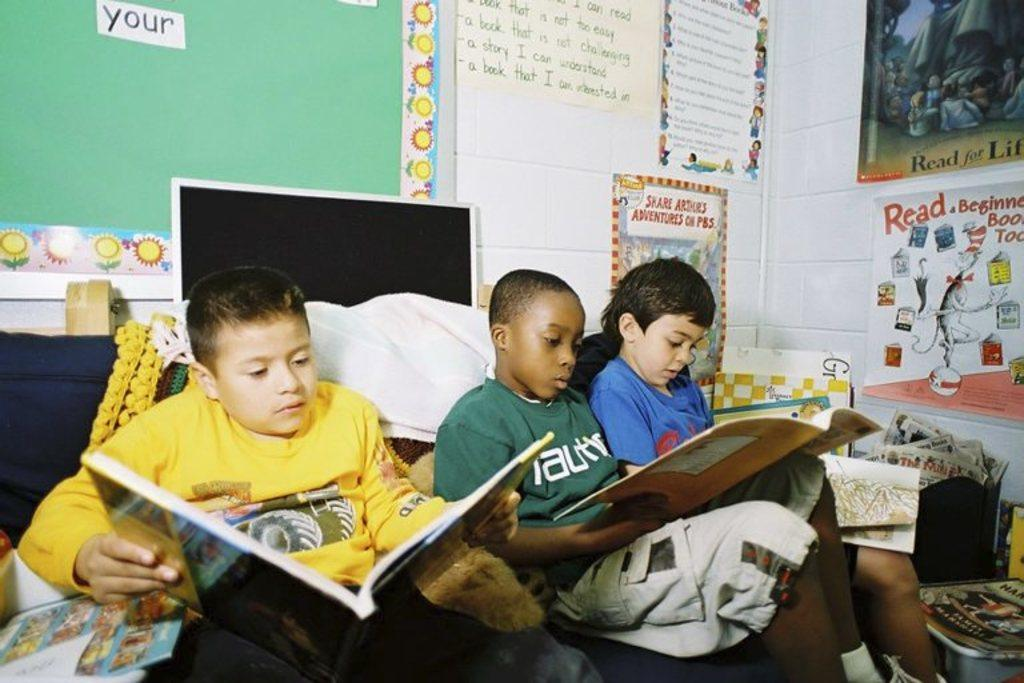<image>
Write a terse but informative summary of the picture. Boys reading in front of a board that says "your" on it. 